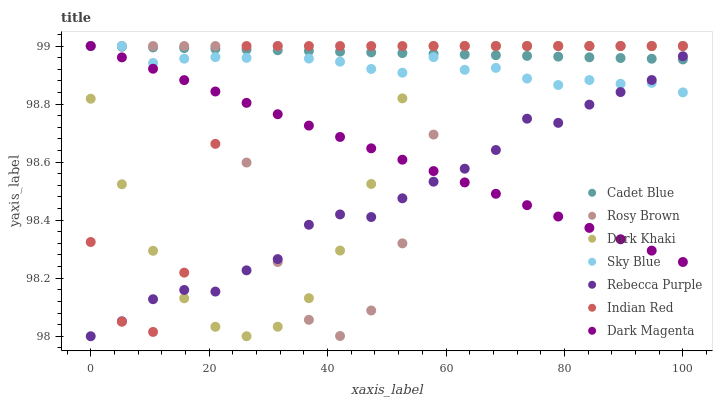Does Rebecca Purple have the minimum area under the curve?
Answer yes or no. Yes. Does Cadet Blue have the maximum area under the curve?
Answer yes or no. Yes. Does Dark Magenta have the minimum area under the curve?
Answer yes or no. No. Does Dark Magenta have the maximum area under the curve?
Answer yes or no. No. Is Cadet Blue the smoothest?
Answer yes or no. Yes. Is Rosy Brown the roughest?
Answer yes or no. Yes. Is Dark Magenta the smoothest?
Answer yes or no. No. Is Dark Magenta the roughest?
Answer yes or no. No. Does Rebecca Purple have the lowest value?
Answer yes or no. Yes. Does Dark Magenta have the lowest value?
Answer yes or no. No. Does Sky Blue have the highest value?
Answer yes or no. Yes. Does Rebecca Purple have the highest value?
Answer yes or no. No. Does Dark Khaki intersect Dark Magenta?
Answer yes or no. Yes. Is Dark Khaki less than Dark Magenta?
Answer yes or no. No. Is Dark Khaki greater than Dark Magenta?
Answer yes or no. No. 